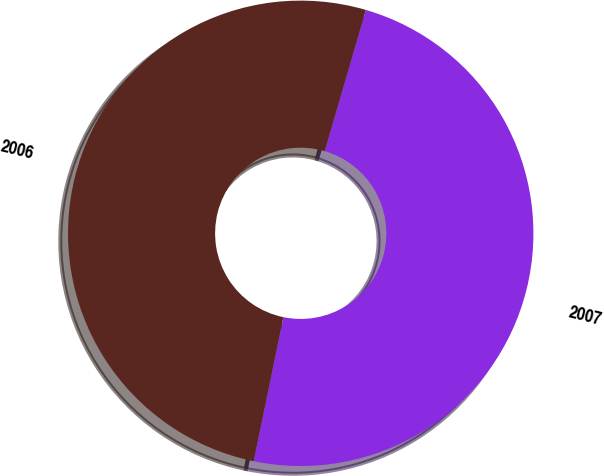Convert chart. <chart><loc_0><loc_0><loc_500><loc_500><pie_chart><fcel>2007<fcel>2006<nl><fcel>48.72%<fcel>51.28%<nl></chart> 